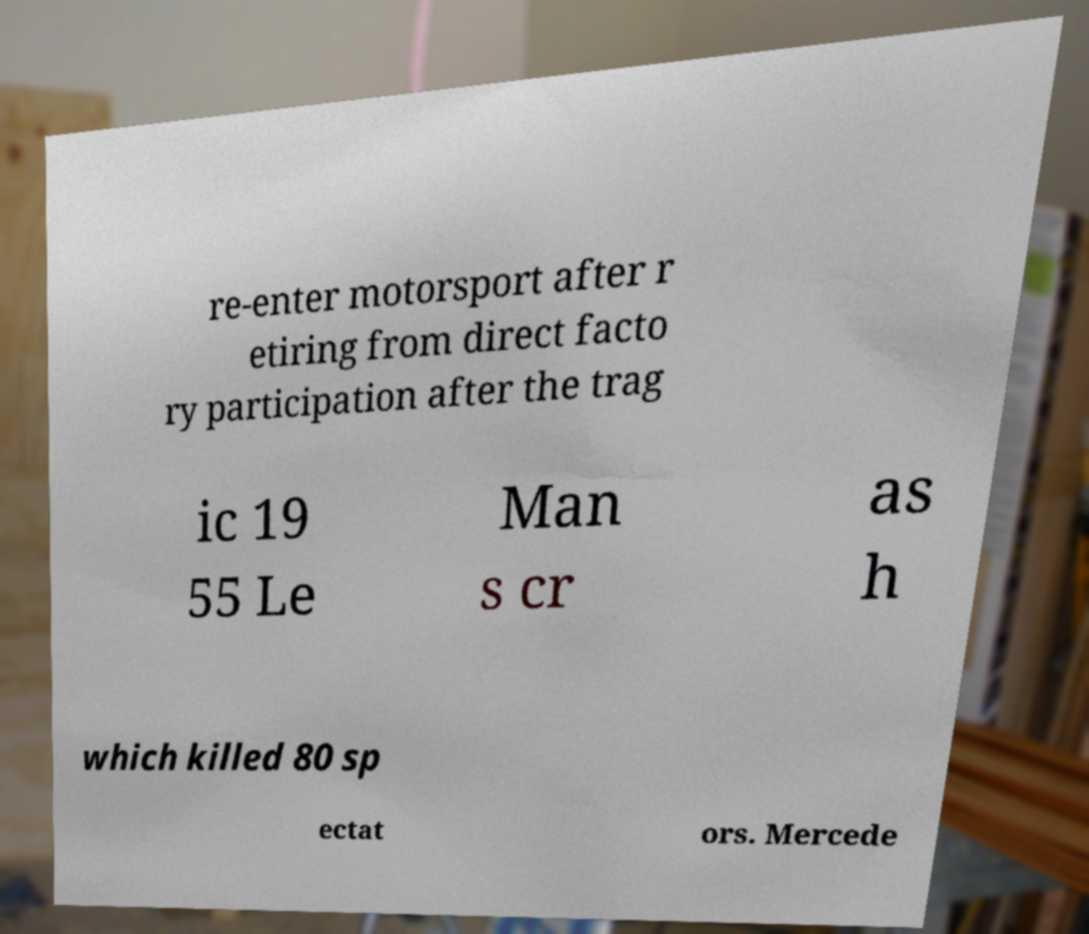Can you accurately transcribe the text from the provided image for me? re-enter motorsport after r etiring from direct facto ry participation after the trag ic 19 55 Le Man s cr as h which killed 80 sp ectat ors. Mercede 